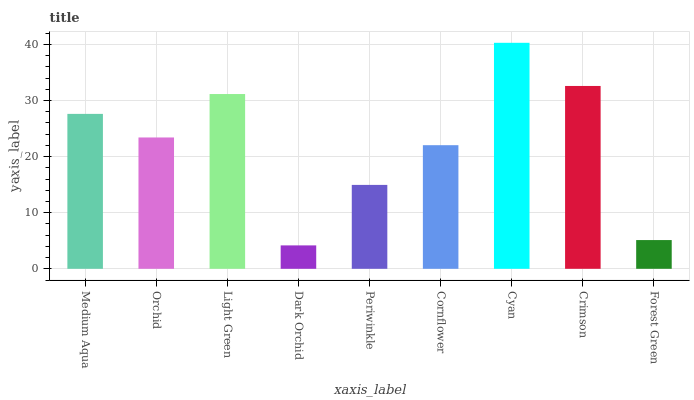Is Dark Orchid the minimum?
Answer yes or no. Yes. Is Cyan the maximum?
Answer yes or no. Yes. Is Orchid the minimum?
Answer yes or no. No. Is Orchid the maximum?
Answer yes or no. No. Is Medium Aqua greater than Orchid?
Answer yes or no. Yes. Is Orchid less than Medium Aqua?
Answer yes or no. Yes. Is Orchid greater than Medium Aqua?
Answer yes or no. No. Is Medium Aqua less than Orchid?
Answer yes or no. No. Is Orchid the high median?
Answer yes or no. Yes. Is Orchid the low median?
Answer yes or no. Yes. Is Dark Orchid the high median?
Answer yes or no. No. Is Medium Aqua the low median?
Answer yes or no. No. 